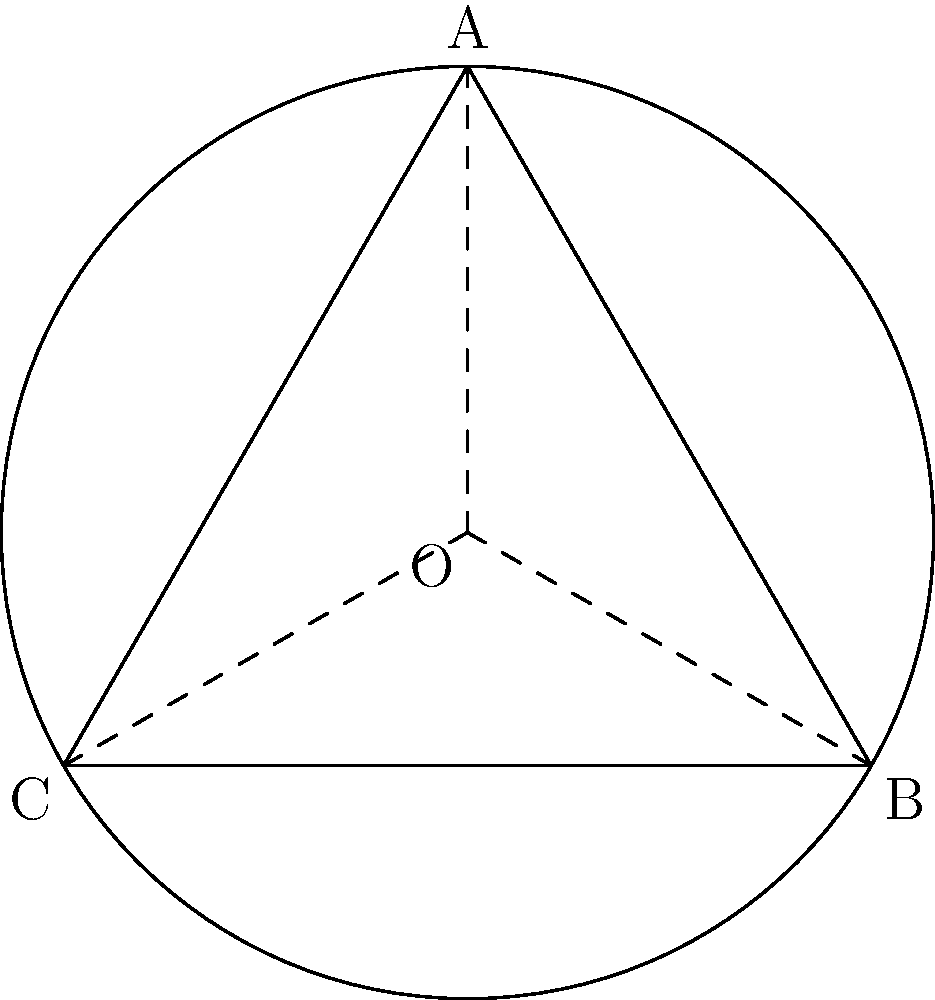A circular park with radius 30 meters contains an inscribed equilateral triangle representing a play area. To optimize green spaces, you need to calculate the difference between the park's total area and the triangle's area. What percentage of the park's total area remains as green space? Let's approach this step-by-step:

1) Area of the circular park:
   $$A_{circle} = \pi r^2 = \pi (30)^2 = 900\pi \text{ m}^2$$

2) For an inscribed equilateral triangle in a circle:
   Side length, $s = r\sqrt{3} = 30\sqrt{3} \text{ m}$

3) Area of the equilateral triangle:
   $$A_{triangle} = \frac{\sqrt{3}}{4}s^2 = \frac{\sqrt{3}}{4}(30\sqrt{3})^2 = 675\sqrt{3} \text{ m}^2$$

4) Green space area:
   $$A_{green} = A_{circle} - A_{triangle} = 900\pi - 675\sqrt{3} \text{ m}^2$$

5) Percentage of green space:
   $$\text{Percentage} = \frac{A_{green}}{A_{circle}} \times 100\% = \frac{900\pi - 675\sqrt{3}}{900\pi} \times 100\%$$

6) Simplify:
   $$= (1 - \frac{675\sqrt{3}}{900\pi}) \times 100\% \approx 58.58\%$$

Therefore, approximately 58.58% of the park's total area remains as green space.
Answer: 58.58% 